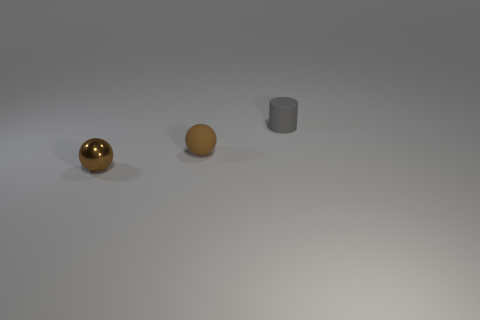How might the lighting in the scene affect the perception of the objects? The lighting in the scene has a soft, diffuse quality, casting gentle shadows and subtle highlights on the objects. This type of lighting softens the texture and contours of the objects, which can affect their perceived material properties. For the shiny sphere, it emphasizes its reflectiveness and for the matte objects, it accentuates their solidity and volume. 